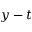Convert formula to latex. <formula><loc_0><loc_0><loc_500><loc_500>y - t</formula> 